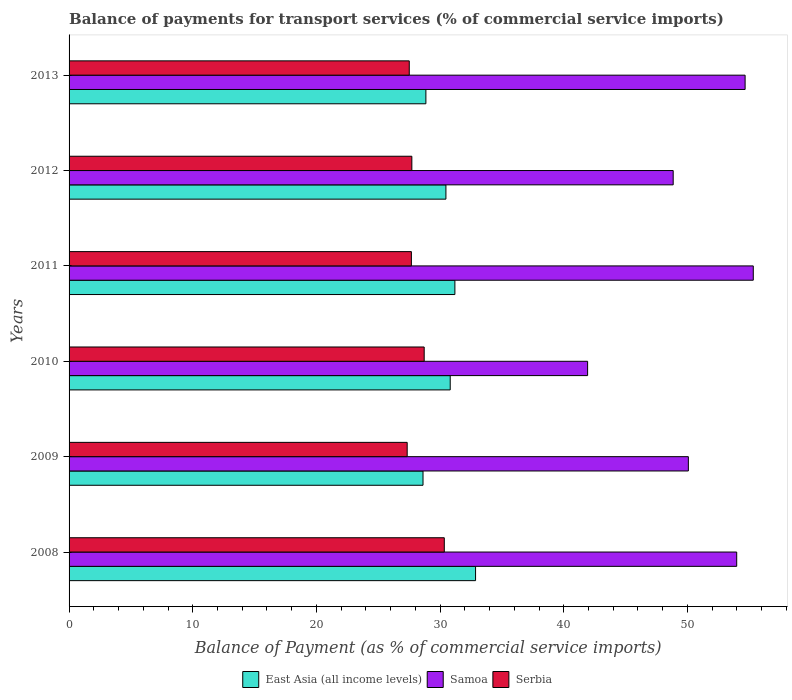How many different coloured bars are there?
Ensure brevity in your answer.  3. How many groups of bars are there?
Ensure brevity in your answer.  6. In how many cases, is the number of bars for a given year not equal to the number of legend labels?
Provide a succinct answer. 0. What is the balance of payments for transport services in East Asia (all income levels) in 2011?
Provide a short and direct response. 31.2. Across all years, what is the maximum balance of payments for transport services in Samoa?
Offer a terse response. 55.32. Across all years, what is the minimum balance of payments for transport services in East Asia (all income levels)?
Make the answer very short. 28.62. In which year was the balance of payments for transport services in Samoa minimum?
Make the answer very short. 2010. What is the total balance of payments for transport services in East Asia (all income levels) in the graph?
Offer a terse response. 182.82. What is the difference between the balance of payments for transport services in Serbia in 2010 and that in 2012?
Offer a terse response. 1. What is the difference between the balance of payments for transport services in East Asia (all income levels) in 2010 and the balance of payments for transport services in Serbia in 2009?
Offer a very short reply. 3.48. What is the average balance of payments for transport services in East Asia (all income levels) per year?
Provide a succinct answer. 30.47. In the year 2008, what is the difference between the balance of payments for transport services in East Asia (all income levels) and balance of payments for transport services in Serbia?
Offer a very short reply. 2.53. In how many years, is the balance of payments for transport services in East Asia (all income levels) greater than 34 %?
Offer a very short reply. 0. What is the ratio of the balance of payments for transport services in Samoa in 2008 to that in 2010?
Your answer should be very brief. 1.29. Is the difference between the balance of payments for transport services in East Asia (all income levels) in 2008 and 2011 greater than the difference between the balance of payments for transport services in Serbia in 2008 and 2011?
Your response must be concise. No. What is the difference between the highest and the second highest balance of payments for transport services in East Asia (all income levels)?
Your answer should be very brief. 1.67. What is the difference between the highest and the lowest balance of payments for transport services in Serbia?
Your answer should be compact. 3. Is the sum of the balance of payments for transport services in Serbia in 2008 and 2010 greater than the maximum balance of payments for transport services in East Asia (all income levels) across all years?
Make the answer very short. Yes. What does the 1st bar from the top in 2013 represents?
Ensure brevity in your answer.  Serbia. What does the 1st bar from the bottom in 2009 represents?
Your response must be concise. East Asia (all income levels). How many years are there in the graph?
Provide a short and direct response. 6. What is the difference between two consecutive major ticks on the X-axis?
Offer a terse response. 10. Are the values on the major ticks of X-axis written in scientific E-notation?
Keep it short and to the point. No. Does the graph contain any zero values?
Offer a terse response. No. Does the graph contain grids?
Provide a succinct answer. No. Where does the legend appear in the graph?
Give a very brief answer. Bottom center. What is the title of the graph?
Make the answer very short. Balance of payments for transport services (% of commercial service imports). What is the label or title of the X-axis?
Offer a very short reply. Balance of Payment (as % of commercial service imports). What is the label or title of the Y-axis?
Keep it short and to the point. Years. What is the Balance of Payment (as % of commercial service imports) of East Asia (all income levels) in 2008?
Make the answer very short. 32.87. What is the Balance of Payment (as % of commercial service imports) in Samoa in 2008?
Keep it short and to the point. 53.98. What is the Balance of Payment (as % of commercial service imports) of Serbia in 2008?
Give a very brief answer. 30.34. What is the Balance of Payment (as % of commercial service imports) in East Asia (all income levels) in 2009?
Offer a terse response. 28.62. What is the Balance of Payment (as % of commercial service imports) of Samoa in 2009?
Provide a succinct answer. 50.07. What is the Balance of Payment (as % of commercial service imports) in Serbia in 2009?
Keep it short and to the point. 27.34. What is the Balance of Payment (as % of commercial service imports) of East Asia (all income levels) in 2010?
Your answer should be compact. 30.82. What is the Balance of Payment (as % of commercial service imports) of Samoa in 2010?
Your response must be concise. 41.93. What is the Balance of Payment (as % of commercial service imports) of Serbia in 2010?
Ensure brevity in your answer.  28.71. What is the Balance of Payment (as % of commercial service imports) in East Asia (all income levels) in 2011?
Ensure brevity in your answer.  31.2. What is the Balance of Payment (as % of commercial service imports) of Samoa in 2011?
Offer a very short reply. 55.32. What is the Balance of Payment (as % of commercial service imports) in Serbia in 2011?
Your answer should be compact. 27.68. What is the Balance of Payment (as % of commercial service imports) of East Asia (all income levels) in 2012?
Provide a short and direct response. 30.47. What is the Balance of Payment (as % of commercial service imports) in Samoa in 2012?
Give a very brief answer. 48.85. What is the Balance of Payment (as % of commercial service imports) of Serbia in 2012?
Your answer should be very brief. 27.72. What is the Balance of Payment (as % of commercial service imports) of East Asia (all income levels) in 2013?
Provide a short and direct response. 28.85. What is the Balance of Payment (as % of commercial service imports) of Samoa in 2013?
Provide a succinct answer. 54.66. What is the Balance of Payment (as % of commercial service imports) in Serbia in 2013?
Your response must be concise. 27.51. Across all years, what is the maximum Balance of Payment (as % of commercial service imports) of East Asia (all income levels)?
Keep it short and to the point. 32.87. Across all years, what is the maximum Balance of Payment (as % of commercial service imports) of Samoa?
Keep it short and to the point. 55.32. Across all years, what is the maximum Balance of Payment (as % of commercial service imports) in Serbia?
Keep it short and to the point. 30.34. Across all years, what is the minimum Balance of Payment (as % of commercial service imports) in East Asia (all income levels)?
Your answer should be very brief. 28.62. Across all years, what is the minimum Balance of Payment (as % of commercial service imports) of Samoa?
Your response must be concise. 41.93. Across all years, what is the minimum Balance of Payment (as % of commercial service imports) of Serbia?
Provide a succinct answer. 27.34. What is the total Balance of Payment (as % of commercial service imports) in East Asia (all income levels) in the graph?
Give a very brief answer. 182.82. What is the total Balance of Payment (as % of commercial service imports) of Samoa in the graph?
Make the answer very short. 304.81. What is the total Balance of Payment (as % of commercial service imports) of Serbia in the graph?
Keep it short and to the point. 169.29. What is the difference between the Balance of Payment (as % of commercial service imports) of East Asia (all income levels) in 2008 and that in 2009?
Give a very brief answer. 4.25. What is the difference between the Balance of Payment (as % of commercial service imports) of Samoa in 2008 and that in 2009?
Your answer should be compact. 3.91. What is the difference between the Balance of Payment (as % of commercial service imports) of Serbia in 2008 and that in 2009?
Your answer should be very brief. 3. What is the difference between the Balance of Payment (as % of commercial service imports) of East Asia (all income levels) in 2008 and that in 2010?
Ensure brevity in your answer.  2.05. What is the difference between the Balance of Payment (as % of commercial service imports) of Samoa in 2008 and that in 2010?
Give a very brief answer. 12.05. What is the difference between the Balance of Payment (as % of commercial service imports) of Serbia in 2008 and that in 2010?
Provide a succinct answer. 1.63. What is the difference between the Balance of Payment (as % of commercial service imports) in East Asia (all income levels) in 2008 and that in 2011?
Give a very brief answer. 1.67. What is the difference between the Balance of Payment (as % of commercial service imports) in Samoa in 2008 and that in 2011?
Make the answer very short. -1.34. What is the difference between the Balance of Payment (as % of commercial service imports) of Serbia in 2008 and that in 2011?
Ensure brevity in your answer.  2.66. What is the difference between the Balance of Payment (as % of commercial service imports) of East Asia (all income levels) in 2008 and that in 2012?
Keep it short and to the point. 2.4. What is the difference between the Balance of Payment (as % of commercial service imports) of Samoa in 2008 and that in 2012?
Your answer should be very brief. 5.13. What is the difference between the Balance of Payment (as % of commercial service imports) of Serbia in 2008 and that in 2012?
Provide a short and direct response. 2.62. What is the difference between the Balance of Payment (as % of commercial service imports) of East Asia (all income levels) in 2008 and that in 2013?
Ensure brevity in your answer.  4.02. What is the difference between the Balance of Payment (as % of commercial service imports) in Samoa in 2008 and that in 2013?
Ensure brevity in your answer.  -0.68. What is the difference between the Balance of Payment (as % of commercial service imports) in Serbia in 2008 and that in 2013?
Give a very brief answer. 2.83. What is the difference between the Balance of Payment (as % of commercial service imports) in East Asia (all income levels) in 2009 and that in 2010?
Make the answer very short. -2.2. What is the difference between the Balance of Payment (as % of commercial service imports) in Samoa in 2009 and that in 2010?
Keep it short and to the point. 8.15. What is the difference between the Balance of Payment (as % of commercial service imports) of Serbia in 2009 and that in 2010?
Keep it short and to the point. -1.38. What is the difference between the Balance of Payment (as % of commercial service imports) in East Asia (all income levels) in 2009 and that in 2011?
Your response must be concise. -2.58. What is the difference between the Balance of Payment (as % of commercial service imports) in Samoa in 2009 and that in 2011?
Ensure brevity in your answer.  -5.25. What is the difference between the Balance of Payment (as % of commercial service imports) of Serbia in 2009 and that in 2011?
Offer a very short reply. -0.34. What is the difference between the Balance of Payment (as % of commercial service imports) of East Asia (all income levels) in 2009 and that in 2012?
Your response must be concise. -1.85. What is the difference between the Balance of Payment (as % of commercial service imports) of Samoa in 2009 and that in 2012?
Your response must be concise. 1.23. What is the difference between the Balance of Payment (as % of commercial service imports) in Serbia in 2009 and that in 2012?
Offer a terse response. -0.38. What is the difference between the Balance of Payment (as % of commercial service imports) of East Asia (all income levels) in 2009 and that in 2013?
Provide a short and direct response. -0.23. What is the difference between the Balance of Payment (as % of commercial service imports) of Samoa in 2009 and that in 2013?
Your answer should be compact. -4.59. What is the difference between the Balance of Payment (as % of commercial service imports) in Serbia in 2009 and that in 2013?
Keep it short and to the point. -0.17. What is the difference between the Balance of Payment (as % of commercial service imports) of East Asia (all income levels) in 2010 and that in 2011?
Offer a terse response. -0.38. What is the difference between the Balance of Payment (as % of commercial service imports) in Samoa in 2010 and that in 2011?
Ensure brevity in your answer.  -13.39. What is the difference between the Balance of Payment (as % of commercial service imports) in Serbia in 2010 and that in 2011?
Ensure brevity in your answer.  1.03. What is the difference between the Balance of Payment (as % of commercial service imports) in East Asia (all income levels) in 2010 and that in 2012?
Your response must be concise. 0.35. What is the difference between the Balance of Payment (as % of commercial service imports) of Samoa in 2010 and that in 2012?
Offer a terse response. -6.92. What is the difference between the Balance of Payment (as % of commercial service imports) of Serbia in 2010 and that in 2012?
Ensure brevity in your answer.  1. What is the difference between the Balance of Payment (as % of commercial service imports) in East Asia (all income levels) in 2010 and that in 2013?
Make the answer very short. 1.97. What is the difference between the Balance of Payment (as % of commercial service imports) of Samoa in 2010 and that in 2013?
Make the answer very short. -12.73. What is the difference between the Balance of Payment (as % of commercial service imports) in Serbia in 2010 and that in 2013?
Provide a short and direct response. 1.21. What is the difference between the Balance of Payment (as % of commercial service imports) in East Asia (all income levels) in 2011 and that in 2012?
Provide a succinct answer. 0.72. What is the difference between the Balance of Payment (as % of commercial service imports) of Samoa in 2011 and that in 2012?
Your answer should be very brief. 6.48. What is the difference between the Balance of Payment (as % of commercial service imports) in Serbia in 2011 and that in 2012?
Provide a succinct answer. -0.04. What is the difference between the Balance of Payment (as % of commercial service imports) in East Asia (all income levels) in 2011 and that in 2013?
Offer a very short reply. 2.34. What is the difference between the Balance of Payment (as % of commercial service imports) in Samoa in 2011 and that in 2013?
Ensure brevity in your answer.  0.66. What is the difference between the Balance of Payment (as % of commercial service imports) of Serbia in 2011 and that in 2013?
Ensure brevity in your answer.  0.17. What is the difference between the Balance of Payment (as % of commercial service imports) of East Asia (all income levels) in 2012 and that in 2013?
Offer a terse response. 1.62. What is the difference between the Balance of Payment (as % of commercial service imports) in Samoa in 2012 and that in 2013?
Keep it short and to the point. -5.82. What is the difference between the Balance of Payment (as % of commercial service imports) in Serbia in 2012 and that in 2013?
Provide a short and direct response. 0.21. What is the difference between the Balance of Payment (as % of commercial service imports) of East Asia (all income levels) in 2008 and the Balance of Payment (as % of commercial service imports) of Samoa in 2009?
Offer a very short reply. -17.21. What is the difference between the Balance of Payment (as % of commercial service imports) in East Asia (all income levels) in 2008 and the Balance of Payment (as % of commercial service imports) in Serbia in 2009?
Your response must be concise. 5.53. What is the difference between the Balance of Payment (as % of commercial service imports) in Samoa in 2008 and the Balance of Payment (as % of commercial service imports) in Serbia in 2009?
Your answer should be compact. 26.64. What is the difference between the Balance of Payment (as % of commercial service imports) in East Asia (all income levels) in 2008 and the Balance of Payment (as % of commercial service imports) in Samoa in 2010?
Give a very brief answer. -9.06. What is the difference between the Balance of Payment (as % of commercial service imports) of East Asia (all income levels) in 2008 and the Balance of Payment (as % of commercial service imports) of Serbia in 2010?
Your response must be concise. 4.15. What is the difference between the Balance of Payment (as % of commercial service imports) of Samoa in 2008 and the Balance of Payment (as % of commercial service imports) of Serbia in 2010?
Provide a short and direct response. 25.27. What is the difference between the Balance of Payment (as % of commercial service imports) of East Asia (all income levels) in 2008 and the Balance of Payment (as % of commercial service imports) of Samoa in 2011?
Provide a short and direct response. -22.46. What is the difference between the Balance of Payment (as % of commercial service imports) of East Asia (all income levels) in 2008 and the Balance of Payment (as % of commercial service imports) of Serbia in 2011?
Provide a short and direct response. 5.19. What is the difference between the Balance of Payment (as % of commercial service imports) of Samoa in 2008 and the Balance of Payment (as % of commercial service imports) of Serbia in 2011?
Make the answer very short. 26.3. What is the difference between the Balance of Payment (as % of commercial service imports) in East Asia (all income levels) in 2008 and the Balance of Payment (as % of commercial service imports) in Samoa in 2012?
Offer a very short reply. -15.98. What is the difference between the Balance of Payment (as % of commercial service imports) in East Asia (all income levels) in 2008 and the Balance of Payment (as % of commercial service imports) in Serbia in 2012?
Keep it short and to the point. 5.15. What is the difference between the Balance of Payment (as % of commercial service imports) of Samoa in 2008 and the Balance of Payment (as % of commercial service imports) of Serbia in 2012?
Ensure brevity in your answer.  26.27. What is the difference between the Balance of Payment (as % of commercial service imports) in East Asia (all income levels) in 2008 and the Balance of Payment (as % of commercial service imports) in Samoa in 2013?
Offer a very short reply. -21.79. What is the difference between the Balance of Payment (as % of commercial service imports) of East Asia (all income levels) in 2008 and the Balance of Payment (as % of commercial service imports) of Serbia in 2013?
Your response must be concise. 5.36. What is the difference between the Balance of Payment (as % of commercial service imports) in Samoa in 2008 and the Balance of Payment (as % of commercial service imports) in Serbia in 2013?
Offer a very short reply. 26.48. What is the difference between the Balance of Payment (as % of commercial service imports) in East Asia (all income levels) in 2009 and the Balance of Payment (as % of commercial service imports) in Samoa in 2010?
Ensure brevity in your answer.  -13.31. What is the difference between the Balance of Payment (as % of commercial service imports) of East Asia (all income levels) in 2009 and the Balance of Payment (as % of commercial service imports) of Serbia in 2010?
Provide a short and direct response. -0.09. What is the difference between the Balance of Payment (as % of commercial service imports) in Samoa in 2009 and the Balance of Payment (as % of commercial service imports) in Serbia in 2010?
Provide a succinct answer. 21.36. What is the difference between the Balance of Payment (as % of commercial service imports) in East Asia (all income levels) in 2009 and the Balance of Payment (as % of commercial service imports) in Samoa in 2011?
Give a very brief answer. -26.7. What is the difference between the Balance of Payment (as % of commercial service imports) in East Asia (all income levels) in 2009 and the Balance of Payment (as % of commercial service imports) in Serbia in 2011?
Your answer should be compact. 0.94. What is the difference between the Balance of Payment (as % of commercial service imports) of Samoa in 2009 and the Balance of Payment (as % of commercial service imports) of Serbia in 2011?
Provide a succinct answer. 22.39. What is the difference between the Balance of Payment (as % of commercial service imports) of East Asia (all income levels) in 2009 and the Balance of Payment (as % of commercial service imports) of Samoa in 2012?
Provide a short and direct response. -20.23. What is the difference between the Balance of Payment (as % of commercial service imports) of East Asia (all income levels) in 2009 and the Balance of Payment (as % of commercial service imports) of Serbia in 2012?
Offer a terse response. 0.9. What is the difference between the Balance of Payment (as % of commercial service imports) of Samoa in 2009 and the Balance of Payment (as % of commercial service imports) of Serbia in 2012?
Provide a succinct answer. 22.36. What is the difference between the Balance of Payment (as % of commercial service imports) of East Asia (all income levels) in 2009 and the Balance of Payment (as % of commercial service imports) of Samoa in 2013?
Keep it short and to the point. -26.04. What is the difference between the Balance of Payment (as % of commercial service imports) of East Asia (all income levels) in 2009 and the Balance of Payment (as % of commercial service imports) of Serbia in 2013?
Provide a succinct answer. 1.11. What is the difference between the Balance of Payment (as % of commercial service imports) of Samoa in 2009 and the Balance of Payment (as % of commercial service imports) of Serbia in 2013?
Your answer should be compact. 22.57. What is the difference between the Balance of Payment (as % of commercial service imports) of East Asia (all income levels) in 2010 and the Balance of Payment (as % of commercial service imports) of Samoa in 2011?
Your response must be concise. -24.5. What is the difference between the Balance of Payment (as % of commercial service imports) in East Asia (all income levels) in 2010 and the Balance of Payment (as % of commercial service imports) in Serbia in 2011?
Provide a succinct answer. 3.14. What is the difference between the Balance of Payment (as % of commercial service imports) in Samoa in 2010 and the Balance of Payment (as % of commercial service imports) in Serbia in 2011?
Your answer should be very brief. 14.25. What is the difference between the Balance of Payment (as % of commercial service imports) of East Asia (all income levels) in 2010 and the Balance of Payment (as % of commercial service imports) of Samoa in 2012?
Offer a very short reply. -18.03. What is the difference between the Balance of Payment (as % of commercial service imports) of East Asia (all income levels) in 2010 and the Balance of Payment (as % of commercial service imports) of Serbia in 2012?
Keep it short and to the point. 3.1. What is the difference between the Balance of Payment (as % of commercial service imports) in Samoa in 2010 and the Balance of Payment (as % of commercial service imports) in Serbia in 2012?
Make the answer very short. 14.21. What is the difference between the Balance of Payment (as % of commercial service imports) in East Asia (all income levels) in 2010 and the Balance of Payment (as % of commercial service imports) in Samoa in 2013?
Keep it short and to the point. -23.84. What is the difference between the Balance of Payment (as % of commercial service imports) of East Asia (all income levels) in 2010 and the Balance of Payment (as % of commercial service imports) of Serbia in 2013?
Offer a very short reply. 3.31. What is the difference between the Balance of Payment (as % of commercial service imports) in Samoa in 2010 and the Balance of Payment (as % of commercial service imports) in Serbia in 2013?
Ensure brevity in your answer.  14.42. What is the difference between the Balance of Payment (as % of commercial service imports) in East Asia (all income levels) in 2011 and the Balance of Payment (as % of commercial service imports) in Samoa in 2012?
Provide a succinct answer. -17.65. What is the difference between the Balance of Payment (as % of commercial service imports) of East Asia (all income levels) in 2011 and the Balance of Payment (as % of commercial service imports) of Serbia in 2012?
Offer a terse response. 3.48. What is the difference between the Balance of Payment (as % of commercial service imports) of Samoa in 2011 and the Balance of Payment (as % of commercial service imports) of Serbia in 2012?
Make the answer very short. 27.61. What is the difference between the Balance of Payment (as % of commercial service imports) in East Asia (all income levels) in 2011 and the Balance of Payment (as % of commercial service imports) in Samoa in 2013?
Provide a short and direct response. -23.47. What is the difference between the Balance of Payment (as % of commercial service imports) in East Asia (all income levels) in 2011 and the Balance of Payment (as % of commercial service imports) in Serbia in 2013?
Offer a terse response. 3.69. What is the difference between the Balance of Payment (as % of commercial service imports) in Samoa in 2011 and the Balance of Payment (as % of commercial service imports) in Serbia in 2013?
Provide a succinct answer. 27.82. What is the difference between the Balance of Payment (as % of commercial service imports) of East Asia (all income levels) in 2012 and the Balance of Payment (as % of commercial service imports) of Samoa in 2013?
Offer a terse response. -24.19. What is the difference between the Balance of Payment (as % of commercial service imports) of East Asia (all income levels) in 2012 and the Balance of Payment (as % of commercial service imports) of Serbia in 2013?
Your answer should be very brief. 2.96. What is the difference between the Balance of Payment (as % of commercial service imports) of Samoa in 2012 and the Balance of Payment (as % of commercial service imports) of Serbia in 2013?
Keep it short and to the point. 21.34. What is the average Balance of Payment (as % of commercial service imports) of East Asia (all income levels) per year?
Your answer should be very brief. 30.47. What is the average Balance of Payment (as % of commercial service imports) of Samoa per year?
Provide a short and direct response. 50.8. What is the average Balance of Payment (as % of commercial service imports) in Serbia per year?
Make the answer very short. 28.21. In the year 2008, what is the difference between the Balance of Payment (as % of commercial service imports) in East Asia (all income levels) and Balance of Payment (as % of commercial service imports) in Samoa?
Your answer should be very brief. -21.11. In the year 2008, what is the difference between the Balance of Payment (as % of commercial service imports) of East Asia (all income levels) and Balance of Payment (as % of commercial service imports) of Serbia?
Provide a short and direct response. 2.53. In the year 2008, what is the difference between the Balance of Payment (as % of commercial service imports) in Samoa and Balance of Payment (as % of commercial service imports) in Serbia?
Make the answer very short. 23.64. In the year 2009, what is the difference between the Balance of Payment (as % of commercial service imports) of East Asia (all income levels) and Balance of Payment (as % of commercial service imports) of Samoa?
Offer a terse response. -21.45. In the year 2009, what is the difference between the Balance of Payment (as % of commercial service imports) of East Asia (all income levels) and Balance of Payment (as % of commercial service imports) of Serbia?
Offer a terse response. 1.28. In the year 2009, what is the difference between the Balance of Payment (as % of commercial service imports) in Samoa and Balance of Payment (as % of commercial service imports) in Serbia?
Provide a succinct answer. 22.73. In the year 2010, what is the difference between the Balance of Payment (as % of commercial service imports) of East Asia (all income levels) and Balance of Payment (as % of commercial service imports) of Samoa?
Provide a succinct answer. -11.11. In the year 2010, what is the difference between the Balance of Payment (as % of commercial service imports) in East Asia (all income levels) and Balance of Payment (as % of commercial service imports) in Serbia?
Provide a short and direct response. 2.1. In the year 2010, what is the difference between the Balance of Payment (as % of commercial service imports) in Samoa and Balance of Payment (as % of commercial service imports) in Serbia?
Ensure brevity in your answer.  13.21. In the year 2011, what is the difference between the Balance of Payment (as % of commercial service imports) of East Asia (all income levels) and Balance of Payment (as % of commercial service imports) of Samoa?
Provide a succinct answer. -24.13. In the year 2011, what is the difference between the Balance of Payment (as % of commercial service imports) in East Asia (all income levels) and Balance of Payment (as % of commercial service imports) in Serbia?
Offer a very short reply. 3.52. In the year 2011, what is the difference between the Balance of Payment (as % of commercial service imports) of Samoa and Balance of Payment (as % of commercial service imports) of Serbia?
Your answer should be compact. 27.64. In the year 2012, what is the difference between the Balance of Payment (as % of commercial service imports) of East Asia (all income levels) and Balance of Payment (as % of commercial service imports) of Samoa?
Your answer should be very brief. -18.38. In the year 2012, what is the difference between the Balance of Payment (as % of commercial service imports) of East Asia (all income levels) and Balance of Payment (as % of commercial service imports) of Serbia?
Make the answer very short. 2.75. In the year 2012, what is the difference between the Balance of Payment (as % of commercial service imports) of Samoa and Balance of Payment (as % of commercial service imports) of Serbia?
Provide a short and direct response. 21.13. In the year 2013, what is the difference between the Balance of Payment (as % of commercial service imports) in East Asia (all income levels) and Balance of Payment (as % of commercial service imports) in Samoa?
Your response must be concise. -25.81. In the year 2013, what is the difference between the Balance of Payment (as % of commercial service imports) in East Asia (all income levels) and Balance of Payment (as % of commercial service imports) in Serbia?
Ensure brevity in your answer.  1.35. In the year 2013, what is the difference between the Balance of Payment (as % of commercial service imports) of Samoa and Balance of Payment (as % of commercial service imports) of Serbia?
Your answer should be compact. 27.16. What is the ratio of the Balance of Payment (as % of commercial service imports) of East Asia (all income levels) in 2008 to that in 2009?
Your answer should be compact. 1.15. What is the ratio of the Balance of Payment (as % of commercial service imports) in Samoa in 2008 to that in 2009?
Your response must be concise. 1.08. What is the ratio of the Balance of Payment (as % of commercial service imports) of Serbia in 2008 to that in 2009?
Ensure brevity in your answer.  1.11. What is the ratio of the Balance of Payment (as % of commercial service imports) of East Asia (all income levels) in 2008 to that in 2010?
Make the answer very short. 1.07. What is the ratio of the Balance of Payment (as % of commercial service imports) of Samoa in 2008 to that in 2010?
Your answer should be compact. 1.29. What is the ratio of the Balance of Payment (as % of commercial service imports) in Serbia in 2008 to that in 2010?
Ensure brevity in your answer.  1.06. What is the ratio of the Balance of Payment (as % of commercial service imports) in East Asia (all income levels) in 2008 to that in 2011?
Offer a terse response. 1.05. What is the ratio of the Balance of Payment (as % of commercial service imports) of Samoa in 2008 to that in 2011?
Your answer should be compact. 0.98. What is the ratio of the Balance of Payment (as % of commercial service imports) of Serbia in 2008 to that in 2011?
Keep it short and to the point. 1.1. What is the ratio of the Balance of Payment (as % of commercial service imports) in East Asia (all income levels) in 2008 to that in 2012?
Your response must be concise. 1.08. What is the ratio of the Balance of Payment (as % of commercial service imports) in Samoa in 2008 to that in 2012?
Provide a short and direct response. 1.11. What is the ratio of the Balance of Payment (as % of commercial service imports) of Serbia in 2008 to that in 2012?
Ensure brevity in your answer.  1.09. What is the ratio of the Balance of Payment (as % of commercial service imports) of East Asia (all income levels) in 2008 to that in 2013?
Provide a short and direct response. 1.14. What is the ratio of the Balance of Payment (as % of commercial service imports) of Samoa in 2008 to that in 2013?
Your answer should be very brief. 0.99. What is the ratio of the Balance of Payment (as % of commercial service imports) in Serbia in 2008 to that in 2013?
Your answer should be compact. 1.1. What is the ratio of the Balance of Payment (as % of commercial service imports) in East Asia (all income levels) in 2009 to that in 2010?
Offer a terse response. 0.93. What is the ratio of the Balance of Payment (as % of commercial service imports) of Samoa in 2009 to that in 2010?
Your response must be concise. 1.19. What is the ratio of the Balance of Payment (as % of commercial service imports) in Serbia in 2009 to that in 2010?
Offer a terse response. 0.95. What is the ratio of the Balance of Payment (as % of commercial service imports) in East Asia (all income levels) in 2009 to that in 2011?
Keep it short and to the point. 0.92. What is the ratio of the Balance of Payment (as % of commercial service imports) of Samoa in 2009 to that in 2011?
Provide a succinct answer. 0.91. What is the ratio of the Balance of Payment (as % of commercial service imports) in Serbia in 2009 to that in 2011?
Keep it short and to the point. 0.99. What is the ratio of the Balance of Payment (as % of commercial service imports) of East Asia (all income levels) in 2009 to that in 2012?
Your response must be concise. 0.94. What is the ratio of the Balance of Payment (as % of commercial service imports) of Samoa in 2009 to that in 2012?
Your answer should be very brief. 1.03. What is the ratio of the Balance of Payment (as % of commercial service imports) of Serbia in 2009 to that in 2012?
Provide a short and direct response. 0.99. What is the ratio of the Balance of Payment (as % of commercial service imports) in Samoa in 2009 to that in 2013?
Provide a short and direct response. 0.92. What is the ratio of the Balance of Payment (as % of commercial service imports) in Serbia in 2009 to that in 2013?
Offer a terse response. 0.99. What is the ratio of the Balance of Payment (as % of commercial service imports) in East Asia (all income levels) in 2010 to that in 2011?
Your answer should be very brief. 0.99. What is the ratio of the Balance of Payment (as % of commercial service imports) in Samoa in 2010 to that in 2011?
Provide a short and direct response. 0.76. What is the ratio of the Balance of Payment (as % of commercial service imports) of Serbia in 2010 to that in 2011?
Your answer should be compact. 1.04. What is the ratio of the Balance of Payment (as % of commercial service imports) of East Asia (all income levels) in 2010 to that in 2012?
Your response must be concise. 1.01. What is the ratio of the Balance of Payment (as % of commercial service imports) in Samoa in 2010 to that in 2012?
Provide a short and direct response. 0.86. What is the ratio of the Balance of Payment (as % of commercial service imports) in Serbia in 2010 to that in 2012?
Offer a very short reply. 1.04. What is the ratio of the Balance of Payment (as % of commercial service imports) in East Asia (all income levels) in 2010 to that in 2013?
Give a very brief answer. 1.07. What is the ratio of the Balance of Payment (as % of commercial service imports) in Samoa in 2010 to that in 2013?
Keep it short and to the point. 0.77. What is the ratio of the Balance of Payment (as % of commercial service imports) in Serbia in 2010 to that in 2013?
Ensure brevity in your answer.  1.04. What is the ratio of the Balance of Payment (as % of commercial service imports) of East Asia (all income levels) in 2011 to that in 2012?
Your answer should be compact. 1.02. What is the ratio of the Balance of Payment (as % of commercial service imports) of Samoa in 2011 to that in 2012?
Your answer should be very brief. 1.13. What is the ratio of the Balance of Payment (as % of commercial service imports) of Serbia in 2011 to that in 2012?
Offer a very short reply. 1. What is the ratio of the Balance of Payment (as % of commercial service imports) of East Asia (all income levels) in 2011 to that in 2013?
Keep it short and to the point. 1.08. What is the ratio of the Balance of Payment (as % of commercial service imports) in Samoa in 2011 to that in 2013?
Provide a succinct answer. 1.01. What is the ratio of the Balance of Payment (as % of commercial service imports) in East Asia (all income levels) in 2012 to that in 2013?
Provide a short and direct response. 1.06. What is the ratio of the Balance of Payment (as % of commercial service imports) of Samoa in 2012 to that in 2013?
Keep it short and to the point. 0.89. What is the ratio of the Balance of Payment (as % of commercial service imports) of Serbia in 2012 to that in 2013?
Provide a succinct answer. 1.01. What is the difference between the highest and the second highest Balance of Payment (as % of commercial service imports) of East Asia (all income levels)?
Your response must be concise. 1.67. What is the difference between the highest and the second highest Balance of Payment (as % of commercial service imports) in Samoa?
Your answer should be very brief. 0.66. What is the difference between the highest and the second highest Balance of Payment (as % of commercial service imports) of Serbia?
Ensure brevity in your answer.  1.63. What is the difference between the highest and the lowest Balance of Payment (as % of commercial service imports) of East Asia (all income levels)?
Keep it short and to the point. 4.25. What is the difference between the highest and the lowest Balance of Payment (as % of commercial service imports) of Samoa?
Give a very brief answer. 13.39. What is the difference between the highest and the lowest Balance of Payment (as % of commercial service imports) in Serbia?
Offer a very short reply. 3. 